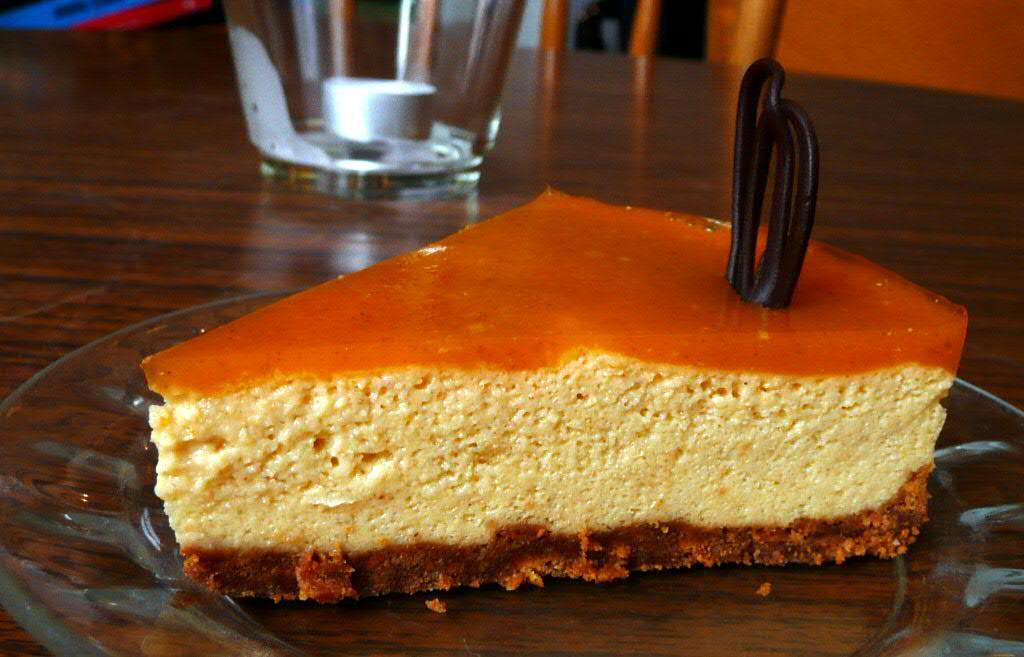What is the main food item visible in the image? There is a piece of cake in the image. What is the cake placed on? The cake is on a glass plate. What type of surface is the cake and plate on? The image appears to depict a table. What other items can be seen on the table? There is a plate and a glass on the table. What type of ship is sailing in the background of the image? There is no ship visible in the image; it only depicts a piece of cake, a glass plate, and items on a table. 